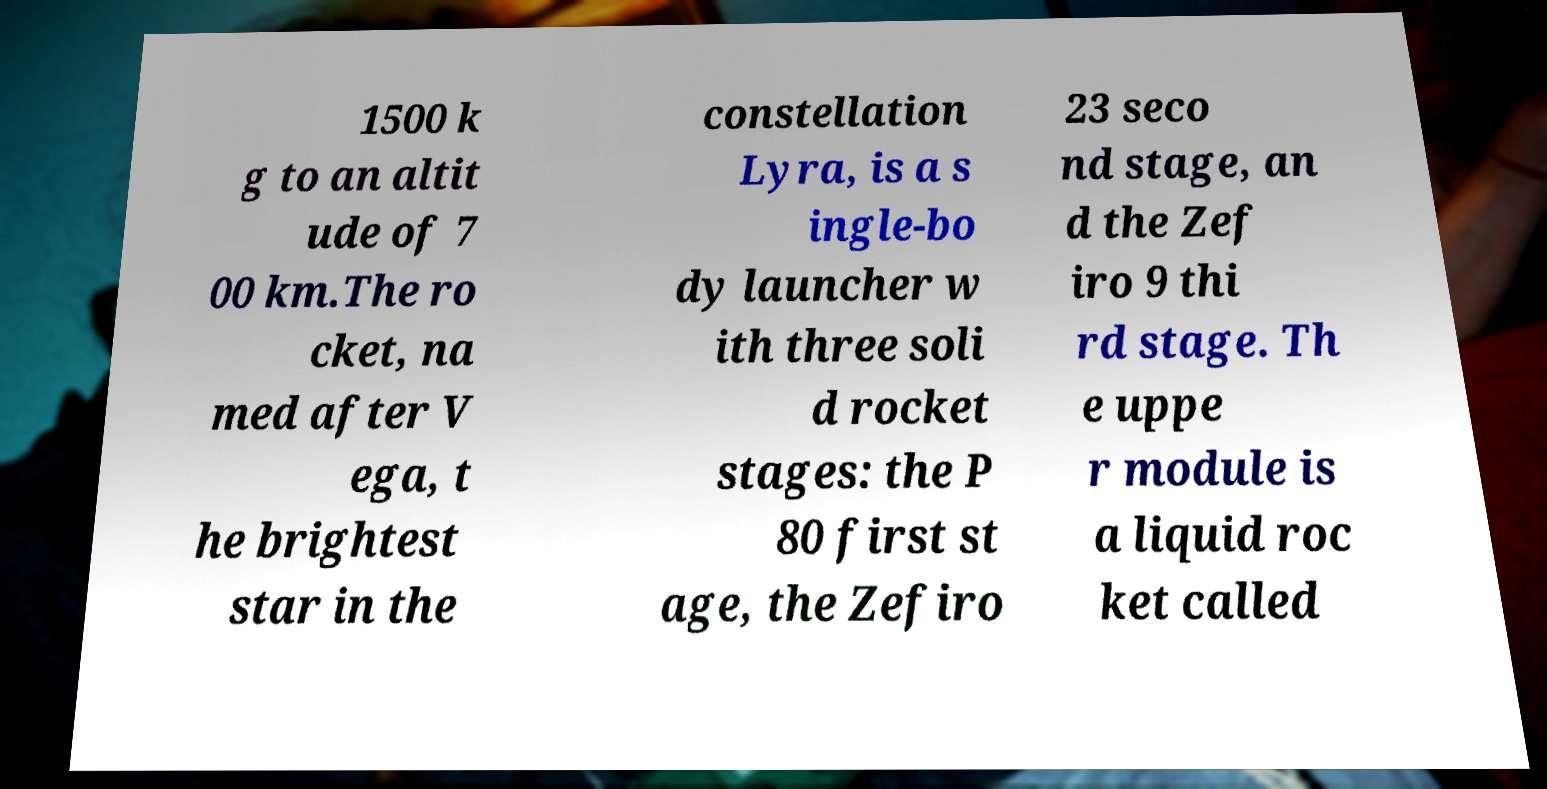For documentation purposes, I need the text within this image transcribed. Could you provide that? 1500 k g to an altit ude of 7 00 km.The ro cket, na med after V ega, t he brightest star in the constellation Lyra, is a s ingle-bo dy launcher w ith three soli d rocket stages: the P 80 first st age, the Zefiro 23 seco nd stage, an d the Zef iro 9 thi rd stage. Th e uppe r module is a liquid roc ket called 